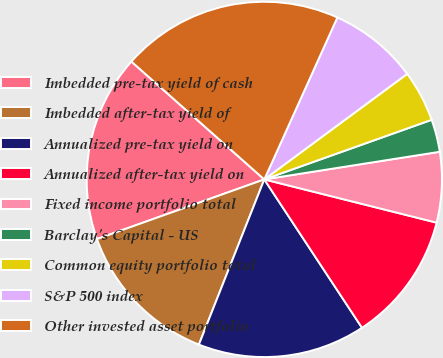Convert chart. <chart><loc_0><loc_0><loc_500><loc_500><pie_chart><fcel>Imbedded pre-tax yield of cash<fcel>Imbedded after-tax yield of<fcel>Annualized pre-tax yield on<fcel>Annualized after-tax yield on<fcel>Fixed income portfolio total<fcel>Barclay's Capital - US<fcel>Common equity portfolio total<fcel>S&P 500 index<fcel>Other invested asset portfolio<nl><fcel>17.0%<fcel>13.55%<fcel>15.27%<fcel>11.82%<fcel>6.4%<fcel>2.96%<fcel>4.68%<fcel>8.13%<fcel>20.2%<nl></chart> 